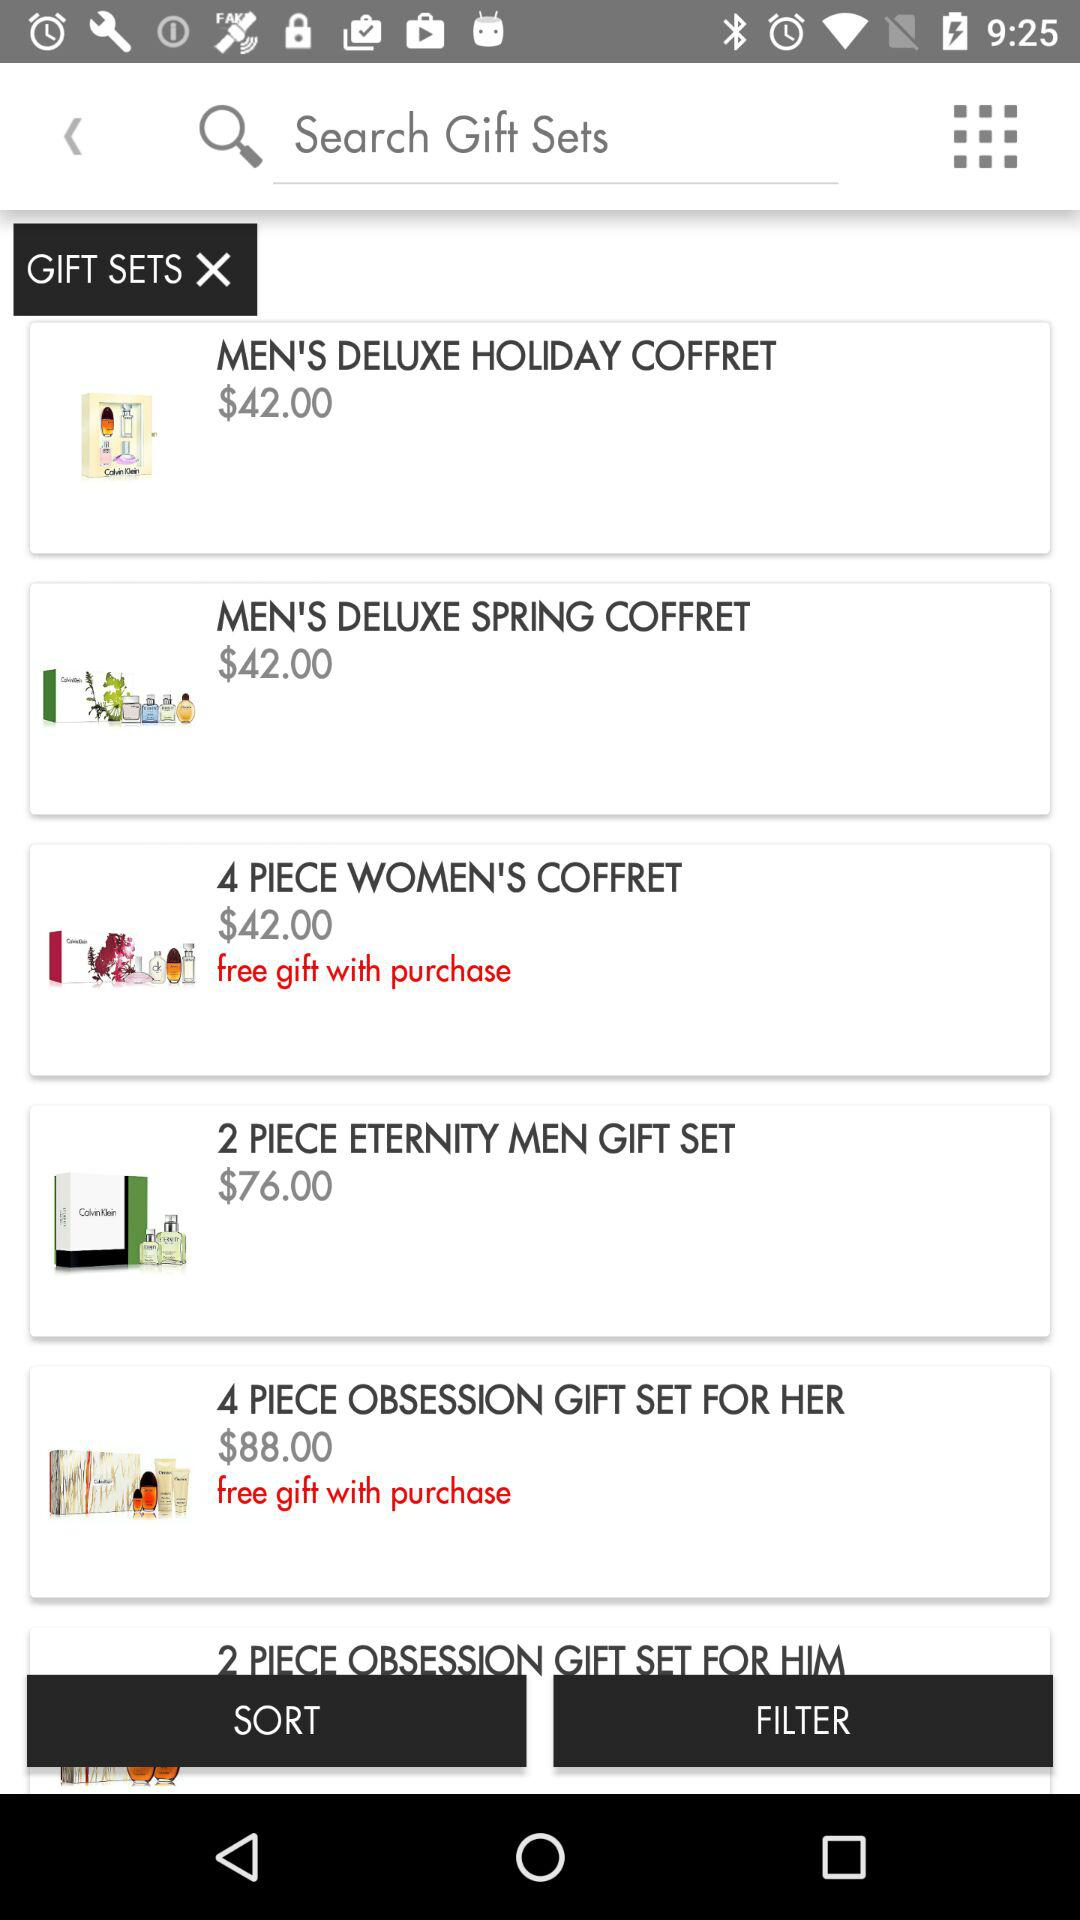How many gift sets have a free gift with purchase?
Answer the question using a single word or phrase. 2 